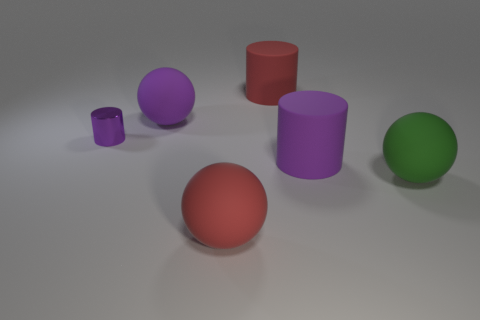Does the green thing have the same size as the shiny cylinder?
Provide a short and direct response. No. There is a thing to the left of the matte sphere that is on the left side of the big red ball; what is its material?
Your answer should be compact. Metal. Is the shape of the thing that is in front of the large green object the same as the red matte object that is behind the large green matte sphere?
Offer a very short reply. No. Are there an equal number of big purple rubber objects that are right of the large red rubber sphere and purple matte balls?
Your answer should be very brief. Yes. There is a red thing that is in front of the green thing; are there any red rubber cylinders in front of it?
Your answer should be very brief. No. Are the large red object in front of the large green matte sphere and the tiny thing made of the same material?
Provide a short and direct response. No. Is the number of big things that are left of the green matte sphere the same as the number of purple shiny objects left of the tiny purple metallic thing?
Provide a succinct answer. No. There is a purple cylinder that is to the left of the large cylinder in front of the small object; what size is it?
Give a very brief answer. Small. There is a thing that is in front of the purple matte ball and on the left side of the red matte sphere; what is its material?
Ensure brevity in your answer.  Metal. What number of other objects are there of the same size as the purple shiny object?
Make the answer very short. 0. 